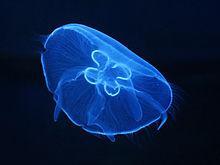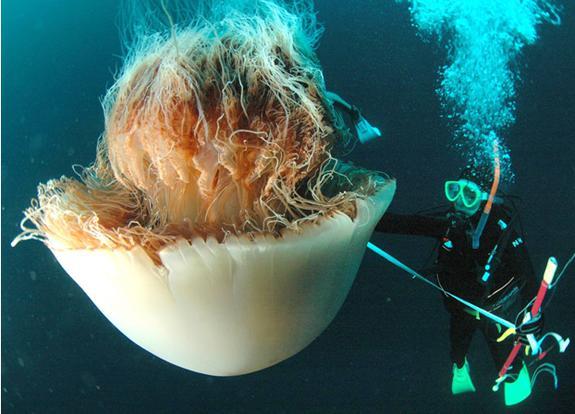The first image is the image on the left, the second image is the image on the right. Examine the images to the left and right. Is the description "There is not less than one scuba diver" accurate? Answer yes or no. Yes. 